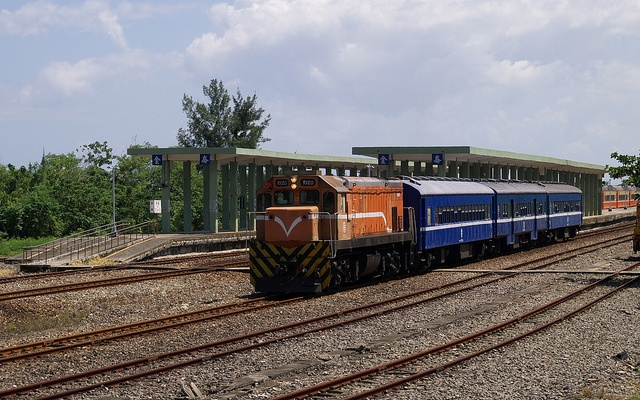Describe the objects in this image and their specific colors. I can see train in darkgray, black, navy, maroon, and gray tones and train in darkgray, gray, tan, and black tones in this image. 